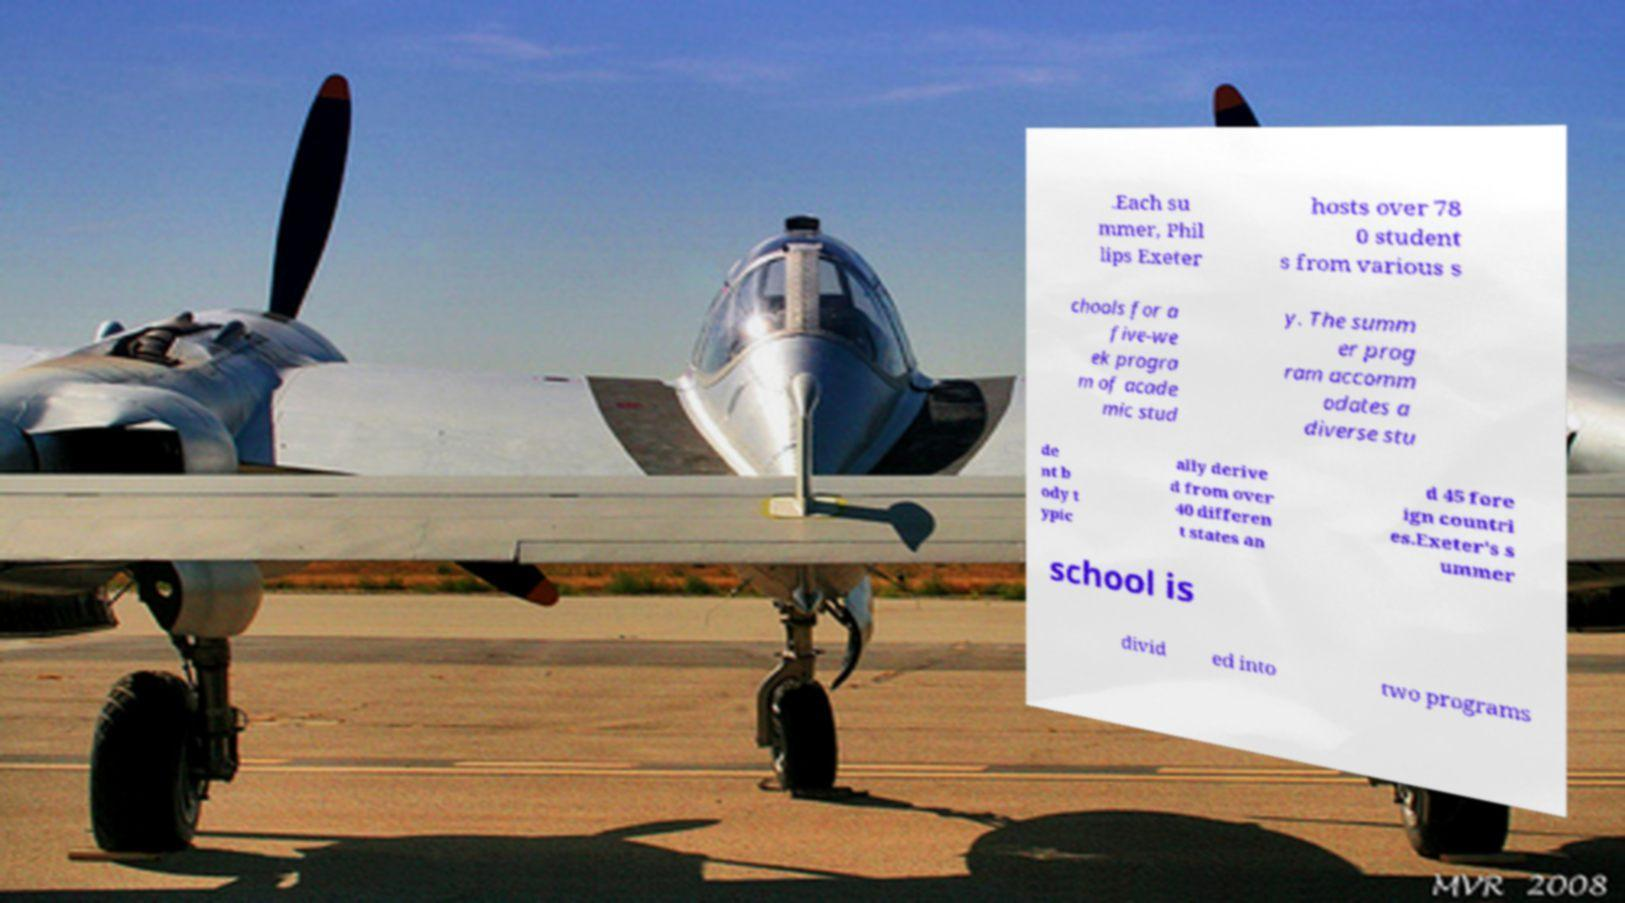I need the written content from this picture converted into text. Can you do that? .Each su mmer, Phil lips Exeter hosts over 78 0 student s from various s chools for a five-we ek progra m of acade mic stud y. The summ er prog ram accomm odates a diverse stu de nt b ody t ypic ally derive d from over 40 differen t states an d 45 fore ign countri es.Exeter's s ummer school is divid ed into two programs 